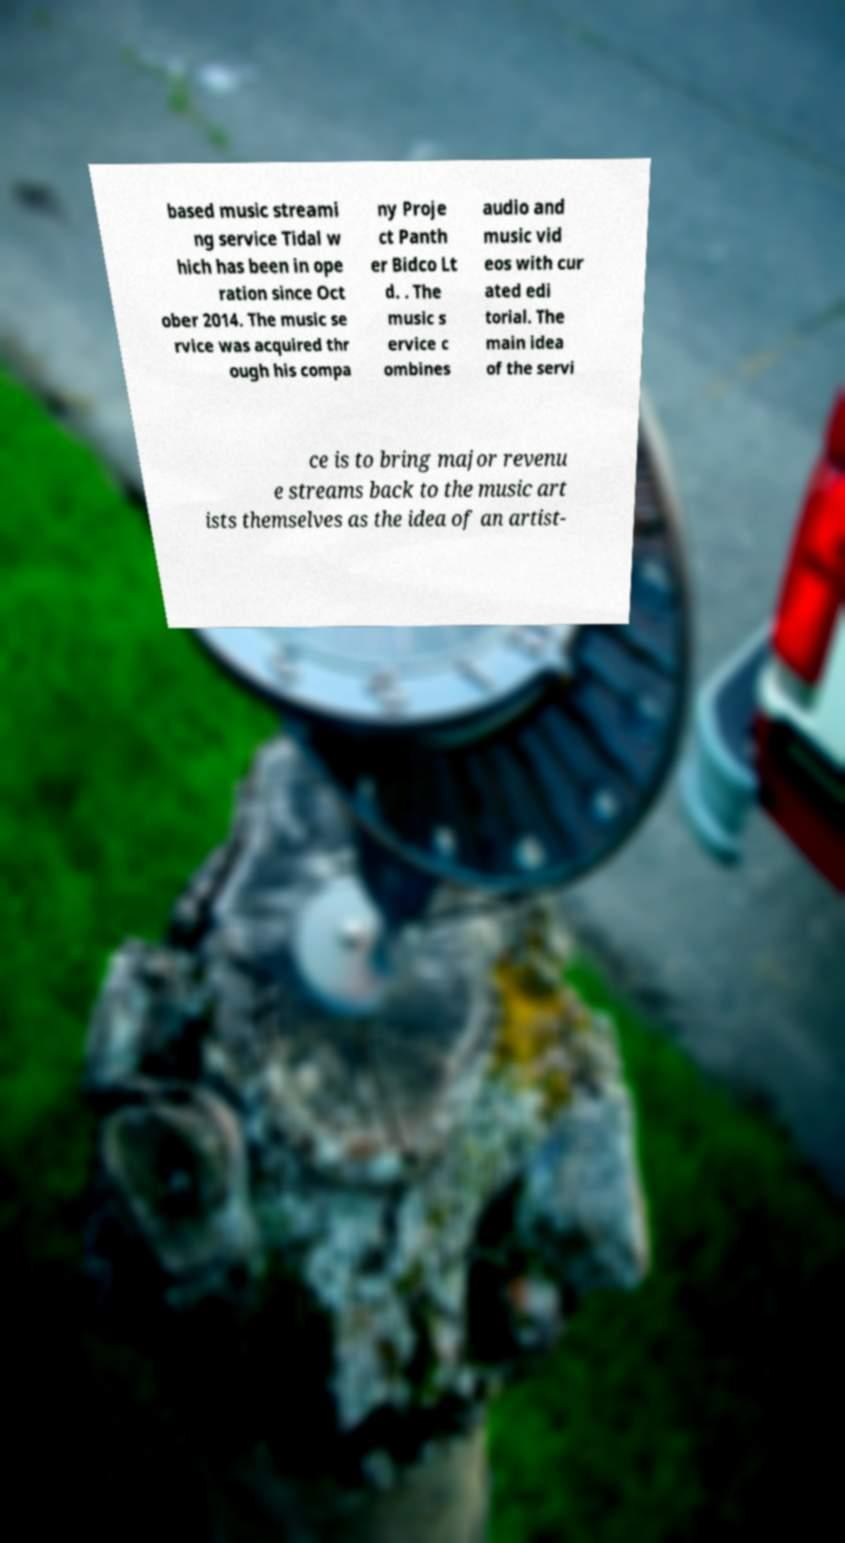Please identify and transcribe the text found in this image. based music streami ng service Tidal w hich has been in ope ration since Oct ober 2014. The music se rvice was acquired thr ough his compa ny Proje ct Panth er Bidco Lt d. . The music s ervice c ombines audio and music vid eos with cur ated edi torial. The main idea of the servi ce is to bring major revenu e streams back to the music art ists themselves as the idea of an artist- 